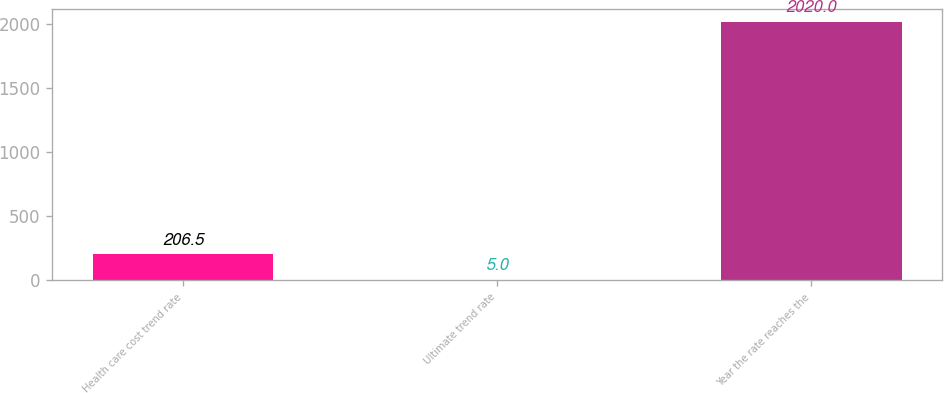Convert chart to OTSL. <chart><loc_0><loc_0><loc_500><loc_500><bar_chart><fcel>Health care cost trend rate<fcel>Ultimate trend rate<fcel>Year the rate reaches the<nl><fcel>206.5<fcel>5<fcel>2020<nl></chart> 